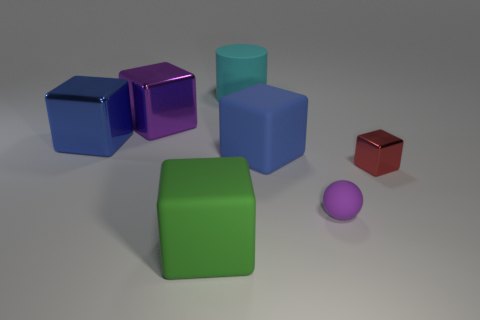Subtract 2 blocks. How many blocks are left? 3 Subtract all green blocks. How many blocks are left? 4 Subtract all cyan blocks. Subtract all green cylinders. How many blocks are left? 5 Add 1 small green metallic objects. How many objects exist? 8 Subtract all cubes. How many objects are left? 2 Subtract all small red cubes. Subtract all tiny purple things. How many objects are left? 5 Add 4 big purple cubes. How many big purple cubes are left? 5 Add 2 purple matte things. How many purple matte things exist? 3 Subtract 0 blue cylinders. How many objects are left? 7 